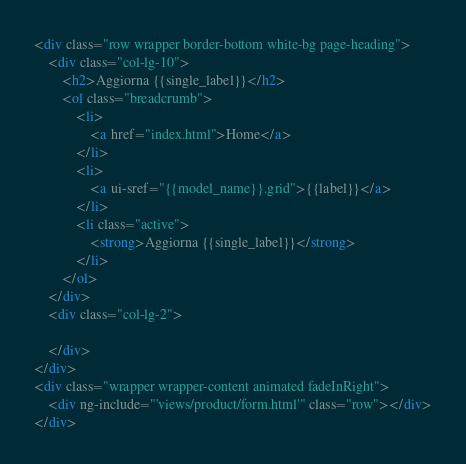<code> <loc_0><loc_0><loc_500><loc_500><_HTML_><div class="row wrapper border-bottom white-bg page-heading">
    <div class="col-lg-10">
        <h2>Aggiorna {{single_label}}</h2>
        <ol class="breadcrumb">
            <li>
                <a href="index.html">Home</a>
            </li>
            <li>
                <a ui-sref="{{model_name}}.grid">{{label}}</a>
            </li>
            <li class="active">
                <strong>Aggiorna {{single_label}}</strong>
            </li>
        </ol>
    </div>
    <div class="col-lg-2">

    </div>
</div>
<div class="wrapper wrapper-content animated fadeInRight">
    <div ng-include="'views/product/form.html'" class="row"></div>
</div>
</code> 